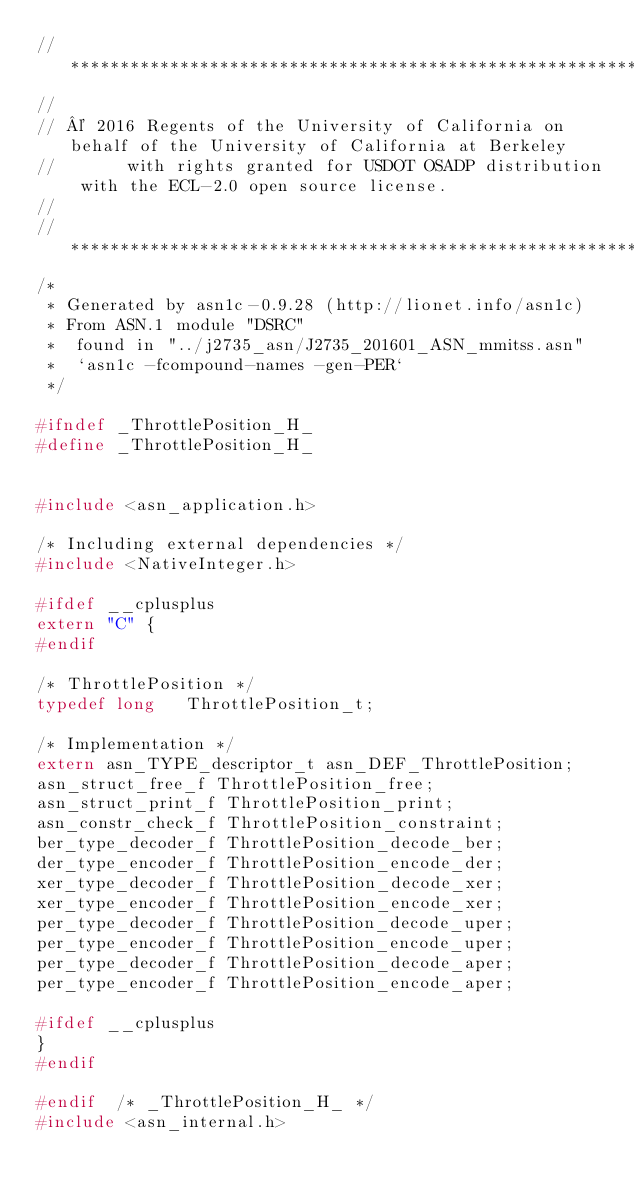<code> <loc_0><loc_0><loc_500><loc_500><_C_>//********************************************************************************************************
//
// © 2016 Regents of the University of California on behalf of the University of California at Berkeley
//       with rights granted for USDOT OSADP distribution with the ECL-2.0 open source license.
//
//*********************************************************************************************************
/*
 * Generated by asn1c-0.9.28 (http://lionet.info/asn1c)
 * From ASN.1 module "DSRC"
 * 	found in "../j2735_asn/J2735_201601_ASN_mmitss.asn"
 * 	`asn1c -fcompound-names -gen-PER`
 */

#ifndef	_ThrottlePosition_H_
#define	_ThrottlePosition_H_


#include <asn_application.h>

/* Including external dependencies */
#include <NativeInteger.h>

#ifdef __cplusplus
extern "C" {
#endif

/* ThrottlePosition */
typedef long	 ThrottlePosition_t;

/* Implementation */
extern asn_TYPE_descriptor_t asn_DEF_ThrottlePosition;
asn_struct_free_f ThrottlePosition_free;
asn_struct_print_f ThrottlePosition_print;
asn_constr_check_f ThrottlePosition_constraint;
ber_type_decoder_f ThrottlePosition_decode_ber;
der_type_encoder_f ThrottlePosition_encode_der;
xer_type_decoder_f ThrottlePosition_decode_xer;
xer_type_encoder_f ThrottlePosition_encode_xer;
per_type_decoder_f ThrottlePosition_decode_uper;
per_type_encoder_f ThrottlePosition_encode_uper;
per_type_decoder_f ThrottlePosition_decode_aper;
per_type_encoder_f ThrottlePosition_encode_aper;

#ifdef __cplusplus
}
#endif

#endif	/* _ThrottlePosition_H_ */
#include <asn_internal.h>
</code> 